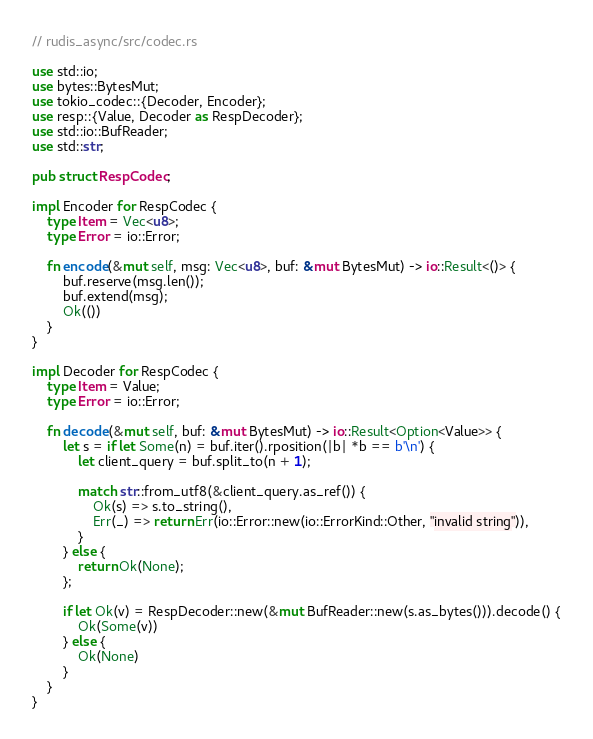Convert code to text. <code><loc_0><loc_0><loc_500><loc_500><_Rust_>// rudis_async/src/codec.rs

use std::io;
use bytes::BytesMut;
use tokio_codec::{Decoder, Encoder};
use resp::{Value, Decoder as RespDecoder};
use std::io::BufReader;
use std::str;

pub struct RespCodec;

impl Encoder for RespCodec {
    type Item = Vec<u8>;
    type Error = io::Error;

    fn encode(&mut self, msg: Vec<u8>, buf: &mut BytesMut) -> io::Result<()> {
        buf.reserve(msg.len());
        buf.extend(msg);
        Ok(())
    }
}

impl Decoder for RespCodec {
    type Item = Value;
    type Error = io::Error;

    fn decode(&mut self, buf: &mut BytesMut) -> io::Result<Option<Value>> {
        let s = if let Some(n) = buf.iter().rposition(|b| *b == b'\n') {
            let client_query = buf.split_to(n + 1);

            match str::from_utf8(&client_query.as_ref()) {
                Ok(s) => s.to_string(),
                Err(_) => return Err(io::Error::new(io::ErrorKind::Other, "invalid string")),
            }
        } else {
            return Ok(None);
        };

        if let Ok(v) = RespDecoder::new(&mut BufReader::new(s.as_bytes())).decode() {
            Ok(Some(v))
        } else {
            Ok(None)
        }
    }
}
</code> 